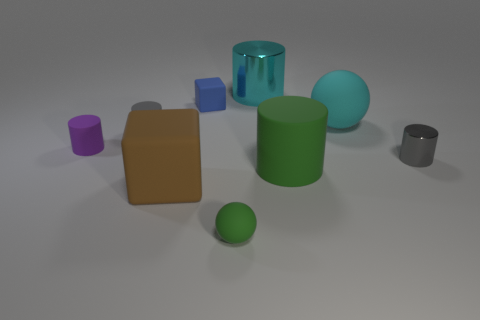Subtract 1 cylinders. How many cylinders are left? 4 Subtract all large green cylinders. How many cylinders are left? 4 Subtract all green cylinders. How many cylinders are left? 4 Add 1 large yellow spheres. How many objects exist? 10 Subtract all red cylinders. Subtract all red balls. How many cylinders are left? 5 Subtract all balls. How many objects are left? 7 Subtract all tiny purple metallic things. Subtract all matte cylinders. How many objects are left? 6 Add 9 big cyan cylinders. How many big cyan cylinders are left? 10 Add 2 small rubber objects. How many small rubber objects exist? 6 Subtract 0 yellow cylinders. How many objects are left? 9 